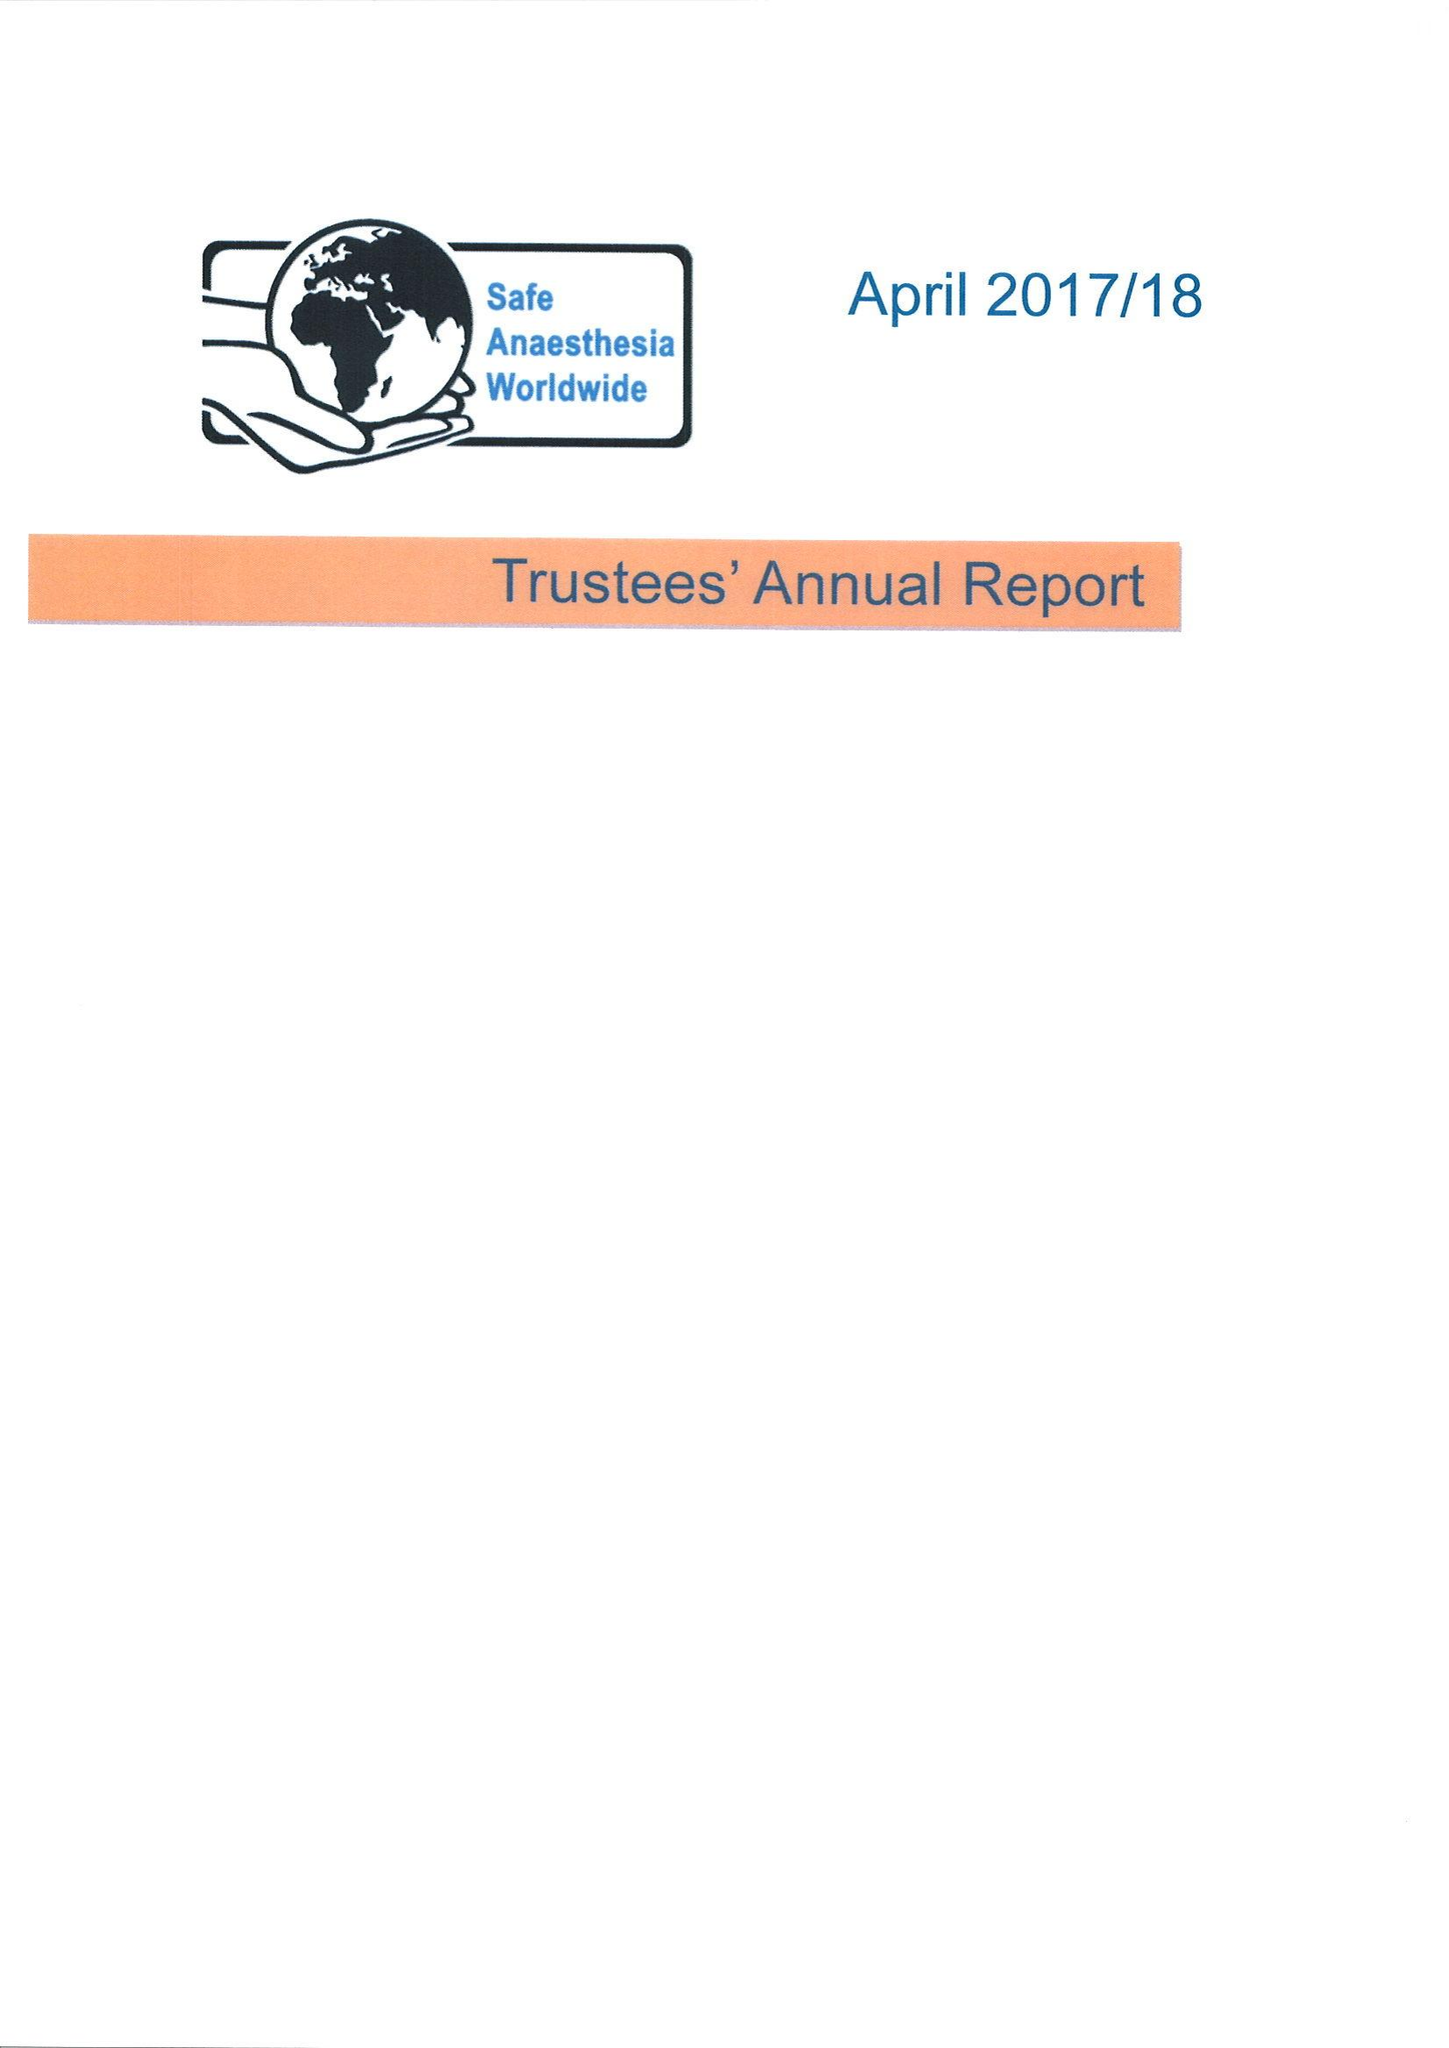What is the value for the spending_annually_in_british_pounds?
Answer the question using a single word or phrase. 53076.00 